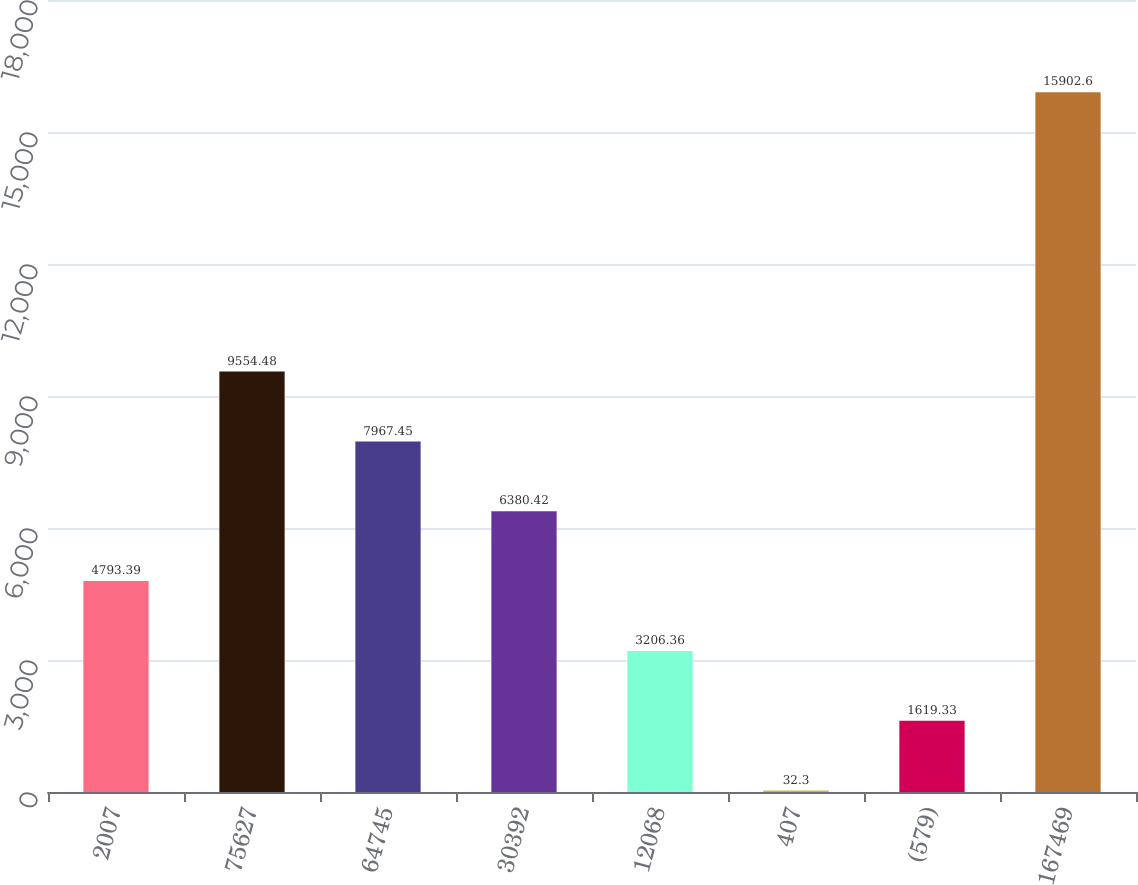<chart> <loc_0><loc_0><loc_500><loc_500><bar_chart><fcel>2007<fcel>75627<fcel>64745<fcel>30392<fcel>12068<fcel>407<fcel>(579)<fcel>167469<nl><fcel>4793.39<fcel>9554.48<fcel>7967.45<fcel>6380.42<fcel>3206.36<fcel>32.3<fcel>1619.33<fcel>15902.6<nl></chart> 